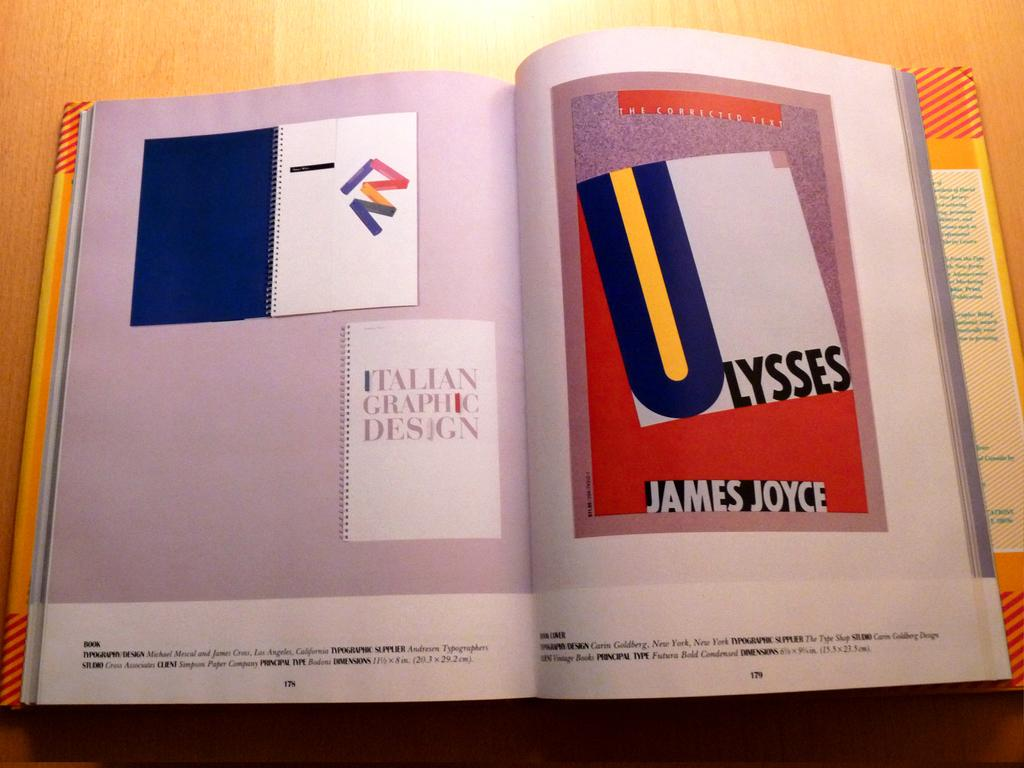<image>
Render a clear and concise summary of the photo. a book which has a print of James Joyce's Ulysees on it 